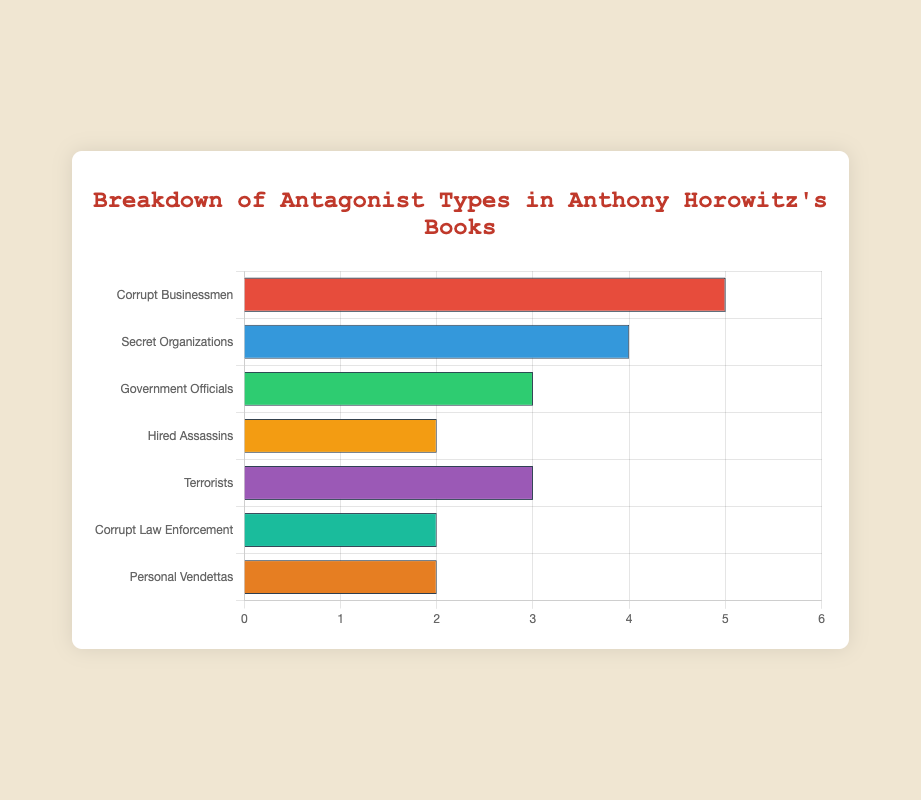What's the most common type of antagonist in Anthony Horowitz's books? By looking at the horizontal bars, the longest bar represents "Corrupt Businessmen" with a count of 5.
Answer: Corrupt Businessmen Which two antagonist types have the same number of occurrences and what is their count? The bars for "Hired Assassins," "Corrupt Law Enforcement," and "Personal Vendettas" all have the same length, indicating they each appear 2 times.
Answer: Hired Assassins and Personal Vendettas, 2 How many antagonist types are there in total in the dataset? By counting the number of bars, there are 7 types of antagonists.
Answer: 7 What is the total number of antagonists listed in the figure? Sum the values of all bars: 5 + 4 + 3 + 2 + 3 + 2 + 2 = 21.
Answer: 21 Which type of antagonist appears more frequently: "Government Officials" or "Terrorists"? Compare the lengths of the two bars. "Government Officials" has a count of 3, and "Terrorists" also has a count of 3, making them equal.
Answer: They are equal To match the count of "Corrupt Businessmen," how many additional antagonists would "Secret Organizations" need? "Corrupt Businessmen" has 5, and "Secret Organizations" has 4. The difference is 5 - 4 = 1.
Answer: 1 What is the average number of occurrences per antagonist type? Sum the values of all bars (21), then divide by the number of types (7). 21 / 7 = 3.
Answer: 3 If the "Personal Vendettas" and "Corrupt Law Enforcement" counts were combined, how many would they total? Add the values of the "Personal Vendettas" and "Corrupt Law Enforcement" bars: 2 + 2 = 4.
Answer: 4 Which antagonist type has a specific shade of green bar? The third bar from the top is "Government Officials" and has a green color.
Answer: Government Officials 